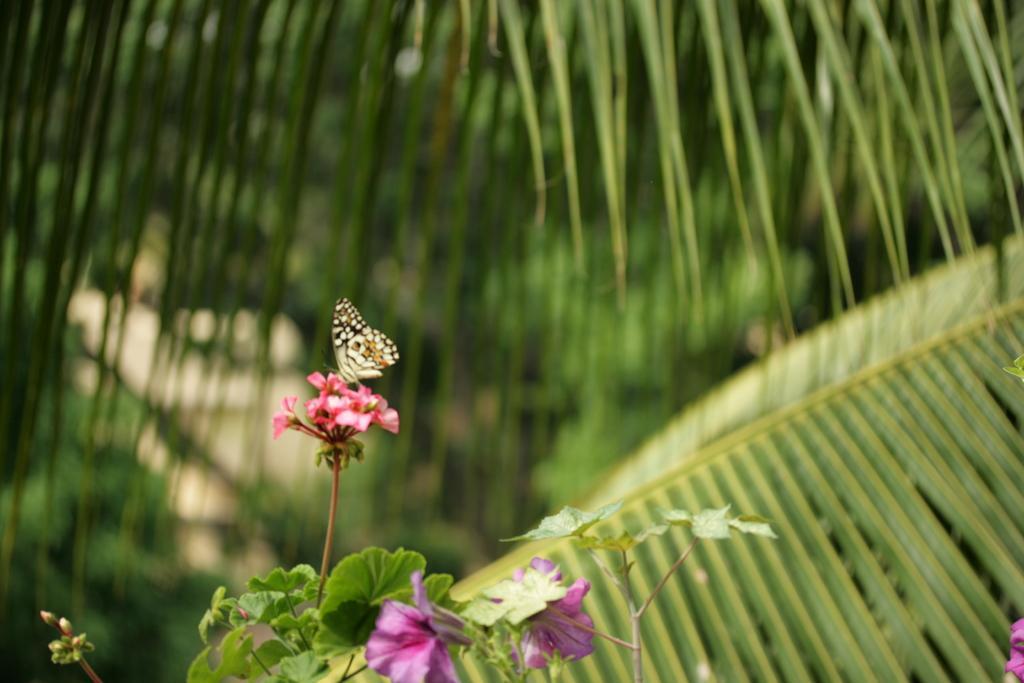Could you give a brief overview of what you see in this image? In the picture I can see a butterfly on flowers. Here I can see trees and flower plants. The background of the image is blurred. 